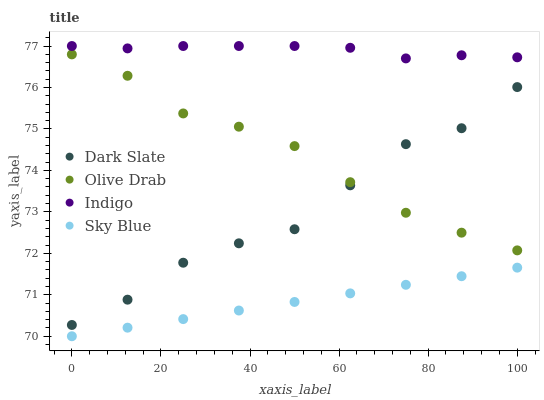Does Sky Blue have the minimum area under the curve?
Answer yes or no. Yes. Does Indigo have the maximum area under the curve?
Answer yes or no. Yes. Does Olive Drab have the minimum area under the curve?
Answer yes or no. No. Does Olive Drab have the maximum area under the curve?
Answer yes or no. No. Is Sky Blue the smoothest?
Answer yes or no. Yes. Is Dark Slate the roughest?
Answer yes or no. Yes. Is Indigo the smoothest?
Answer yes or no. No. Is Indigo the roughest?
Answer yes or no. No. Does Sky Blue have the lowest value?
Answer yes or no. Yes. Does Olive Drab have the lowest value?
Answer yes or no. No. Does Indigo have the highest value?
Answer yes or no. Yes. Does Olive Drab have the highest value?
Answer yes or no. No. Is Sky Blue less than Indigo?
Answer yes or no. Yes. Is Indigo greater than Olive Drab?
Answer yes or no. Yes. Does Dark Slate intersect Olive Drab?
Answer yes or no. Yes. Is Dark Slate less than Olive Drab?
Answer yes or no. No. Is Dark Slate greater than Olive Drab?
Answer yes or no. No. Does Sky Blue intersect Indigo?
Answer yes or no. No. 